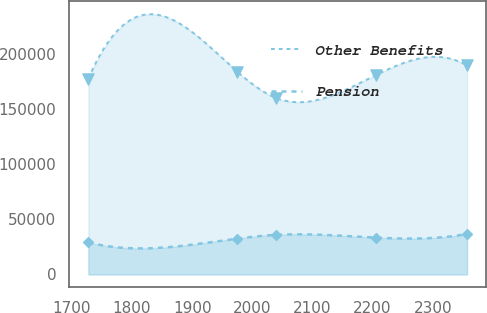<chart> <loc_0><loc_0><loc_500><loc_500><line_chart><ecel><fcel>Other Benefits<fcel>Pension<nl><fcel>1727.48<fcel>177469<fcel>29034.6<nl><fcel>1974.85<fcel>183956<fcel>32448.3<nl><fcel>2039.82<fcel>159934<fcel>35869.2<nl><fcel>2206.34<fcel>181001<fcel>33329.1<nl><fcel>2356.97<fcel>189478<fcel>36622.9<nl></chart> 